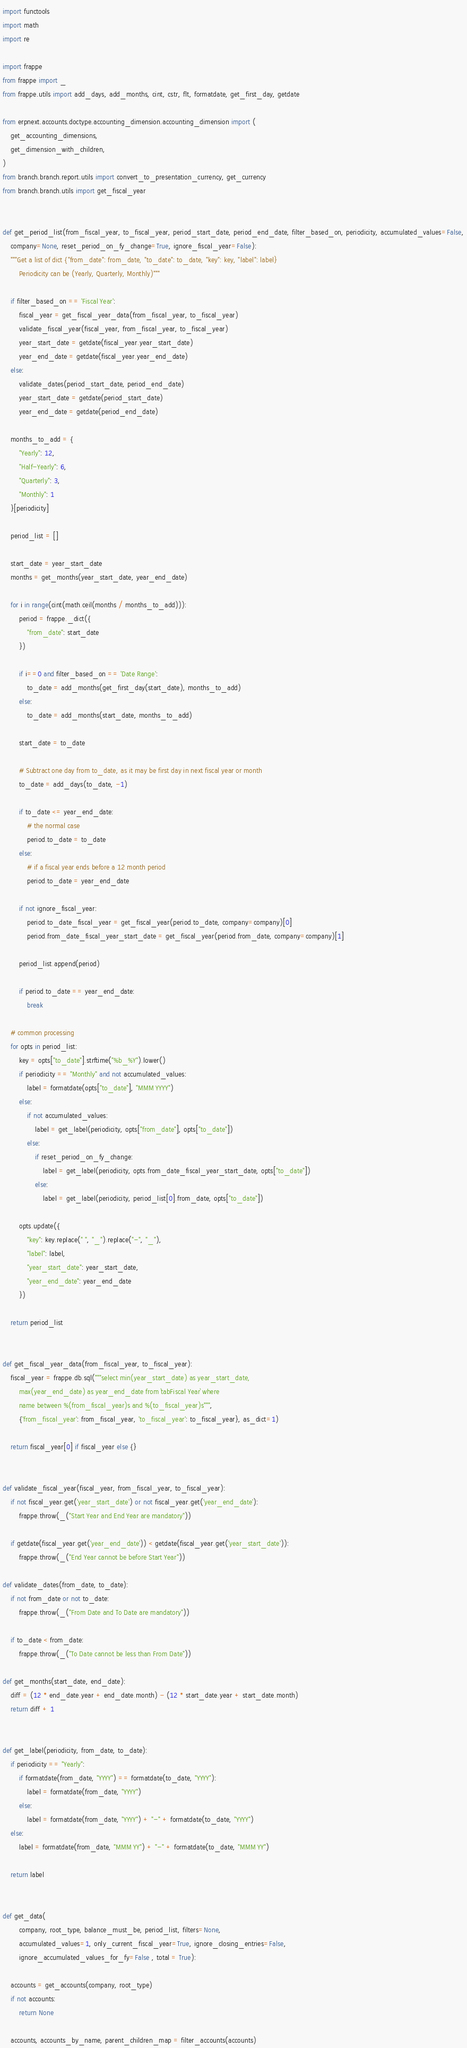Convert code to text. <code><loc_0><loc_0><loc_500><loc_500><_Python_>import functools
import math
import re

import frappe
from frappe import _
from frappe.utils import add_days, add_months, cint, cstr, flt, formatdate, get_first_day, getdate

from erpnext.accounts.doctype.accounting_dimension.accounting_dimension import (
	get_accounting_dimensions,
	get_dimension_with_children,
)
from branch.branch.report.utils import convert_to_presentation_currency, get_currency
from branch.branch.utils import get_fiscal_year


def get_period_list(from_fiscal_year, to_fiscal_year, period_start_date, period_end_date, filter_based_on, periodicity, accumulated_values=False,
	company=None, reset_period_on_fy_change=True, ignore_fiscal_year=False):
	"""Get a list of dict {"from_date": from_date, "to_date": to_date, "key": key, "label": label}
		Periodicity can be (Yearly, Quarterly, Monthly)"""

	if filter_based_on == 'Fiscal Year':
		fiscal_year = get_fiscal_year_data(from_fiscal_year, to_fiscal_year)
		validate_fiscal_year(fiscal_year, from_fiscal_year, to_fiscal_year)
		year_start_date = getdate(fiscal_year.year_start_date)
		year_end_date = getdate(fiscal_year.year_end_date)
	else:
		validate_dates(period_start_date, period_end_date)
		year_start_date = getdate(period_start_date)
		year_end_date = getdate(period_end_date)

	months_to_add = {
		"Yearly": 12,
		"Half-Yearly": 6,
		"Quarterly": 3,
		"Monthly": 1
	}[periodicity]

	period_list = []

	start_date = year_start_date
	months = get_months(year_start_date, year_end_date)

	for i in range(cint(math.ceil(months / months_to_add))):
		period = frappe._dict({
			"from_date": start_date
		})

		if i==0 and filter_based_on == 'Date Range':
			to_date = add_months(get_first_day(start_date), months_to_add)
		else:
			to_date = add_months(start_date, months_to_add)

		start_date = to_date

		# Subtract one day from to_date, as it may be first day in next fiscal year or month
		to_date = add_days(to_date, -1)

		if to_date <= year_end_date:
			# the normal case
			period.to_date = to_date
		else:
			# if a fiscal year ends before a 12 month period
			period.to_date = year_end_date

		if not ignore_fiscal_year:
			period.to_date_fiscal_year = get_fiscal_year(period.to_date, company=company)[0]
			period.from_date_fiscal_year_start_date = get_fiscal_year(period.from_date, company=company)[1]

		period_list.append(period)

		if period.to_date == year_end_date:
			break

	# common processing
	for opts in period_list:
		key = opts["to_date"].strftime("%b_%Y").lower()
		if periodicity == "Monthly" and not accumulated_values:
			label = formatdate(opts["to_date"], "MMM YYYY")
		else:
			if not accumulated_values:
				label = get_label(periodicity, opts["from_date"], opts["to_date"])
			else:
				if reset_period_on_fy_change:
					label = get_label(periodicity, opts.from_date_fiscal_year_start_date, opts["to_date"])
				else:
					label = get_label(periodicity, period_list[0].from_date, opts["to_date"])

		opts.update({
			"key": key.replace(" ", "_").replace("-", "_"),
			"label": label,
			"year_start_date": year_start_date,
			"year_end_date": year_end_date
		})

	return period_list


def get_fiscal_year_data(from_fiscal_year, to_fiscal_year):
	fiscal_year = frappe.db.sql("""select min(year_start_date) as year_start_date,
		max(year_end_date) as year_end_date from `tabFiscal Year` where
		name between %(from_fiscal_year)s and %(to_fiscal_year)s""",
		{'from_fiscal_year': from_fiscal_year, 'to_fiscal_year': to_fiscal_year}, as_dict=1)

	return fiscal_year[0] if fiscal_year else {}


def validate_fiscal_year(fiscal_year, from_fiscal_year, to_fiscal_year):
	if not fiscal_year.get('year_start_date') or not fiscal_year.get('year_end_date'):
		frappe.throw(_("Start Year and End Year are mandatory"))

	if getdate(fiscal_year.get('year_end_date')) < getdate(fiscal_year.get('year_start_date')):
		frappe.throw(_("End Year cannot be before Start Year"))

def validate_dates(from_date, to_date):
	if not from_date or not to_date:
		frappe.throw(_("From Date and To Date are mandatory"))

	if to_date < from_date:
		frappe.throw(_("To Date cannot be less than From Date"))

def get_months(start_date, end_date):
	diff = (12 * end_date.year + end_date.month) - (12 * start_date.year + start_date.month)
	return diff + 1


def get_label(periodicity, from_date, to_date):
	if periodicity == "Yearly":
		if formatdate(from_date, "YYYY") == formatdate(to_date, "YYYY"):
			label = formatdate(from_date, "YYYY")
		else:
			label = formatdate(from_date, "YYYY") + "-" + formatdate(to_date, "YYYY")
	else:
		label = formatdate(from_date, "MMM YY") + "-" + formatdate(to_date, "MMM YY")

	return label


def get_data(
		company, root_type, balance_must_be, period_list, filters=None,
		accumulated_values=1, only_current_fiscal_year=True, ignore_closing_entries=False,
		ignore_accumulated_values_for_fy=False , total = True):

	accounts = get_accounts(company, root_type)
	if not accounts:
		return None

	accounts, accounts_by_name, parent_children_map = filter_accounts(accounts)
</code> 